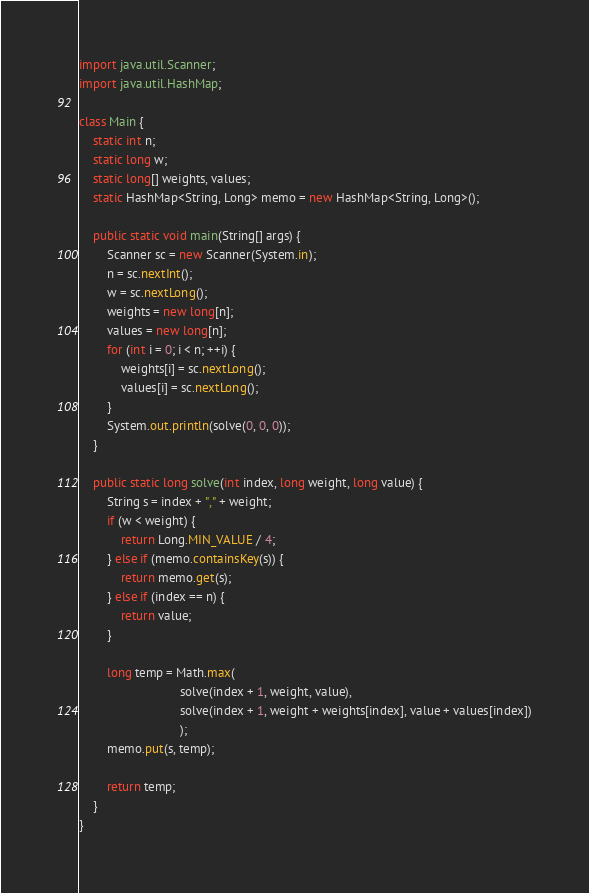Convert code to text. <code><loc_0><loc_0><loc_500><loc_500><_Java_>import java.util.Scanner;
import java.util.HashMap;

class Main {
    static int n;
    static long w;
    static long[] weights, values;
    static HashMap<String, Long> memo = new HashMap<String, Long>();

    public static void main(String[] args) {
        Scanner sc = new Scanner(System.in);
        n = sc.nextInt();
        w = sc.nextLong();
        weights = new long[n];
        values = new long[n];
        for (int i = 0; i < n; ++i) {
            weights[i] = sc.nextLong();
            values[i] = sc.nextLong();
        }
        System.out.println(solve(0, 0, 0));
    }

    public static long solve(int index, long weight, long value) {
        String s = index + "," + weight;
        if (w < weight) {
            return Long.MIN_VALUE / 4;
        } else if (memo.containsKey(s)) {
            return memo.get(s);
        } else if (index == n) {
            return value;
        } 
        
        long temp = Math.max(
                             solve(index + 1, weight, value),
                             solve(index + 1, weight + weights[index], value + values[index])
                             );
        memo.put(s, temp);
        
        return temp;
    }
}
</code> 